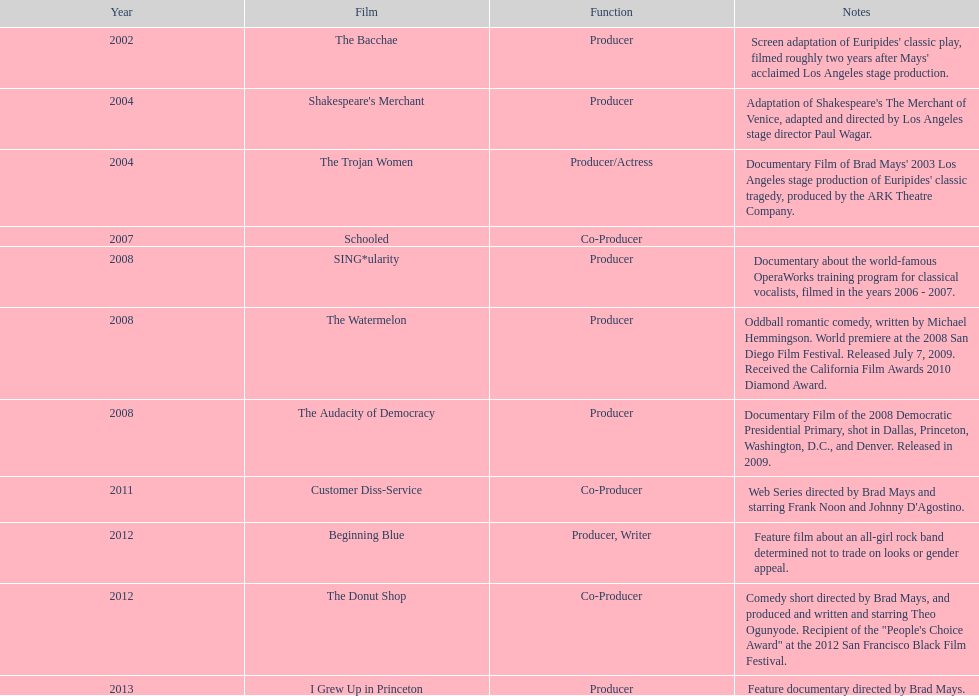In what year did ms. starfelt create the highest number of movies? 2008. 